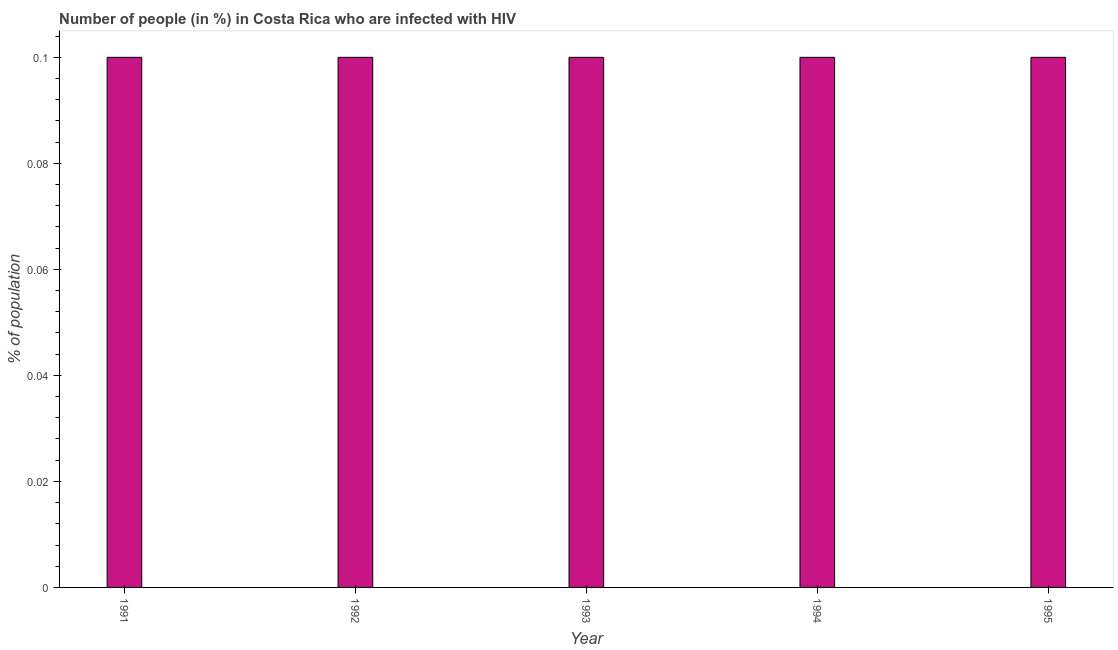Does the graph contain grids?
Offer a terse response. No. What is the title of the graph?
Your answer should be compact. Number of people (in %) in Costa Rica who are infected with HIV. What is the label or title of the Y-axis?
Your answer should be compact. % of population. In which year was the number of people infected with hiv maximum?
Your response must be concise. 1991. What is the sum of the number of people infected with hiv?
Your response must be concise. 0.5. What is the difference between the number of people infected with hiv in 1992 and 1994?
Your answer should be very brief. 0. What is the average number of people infected with hiv per year?
Your response must be concise. 0.1. In how many years, is the number of people infected with hiv greater than 0.084 %?
Ensure brevity in your answer.  5. Is the number of people infected with hiv in 1993 less than that in 1995?
Provide a short and direct response. No. Is the difference between the number of people infected with hiv in 1991 and 1993 greater than the difference between any two years?
Offer a very short reply. Yes. Is the sum of the number of people infected with hiv in 1991 and 1992 greater than the maximum number of people infected with hiv across all years?
Keep it short and to the point. Yes. What is the difference between the highest and the lowest number of people infected with hiv?
Keep it short and to the point. 0. In how many years, is the number of people infected with hiv greater than the average number of people infected with hiv taken over all years?
Give a very brief answer. 0. Are all the bars in the graph horizontal?
Your response must be concise. No. What is the difference between two consecutive major ticks on the Y-axis?
Offer a very short reply. 0.02. Are the values on the major ticks of Y-axis written in scientific E-notation?
Make the answer very short. No. What is the % of population in 1992?
Provide a succinct answer. 0.1. What is the % of population of 1995?
Ensure brevity in your answer.  0.1. What is the difference between the % of population in 1991 and 1992?
Make the answer very short. 0. What is the difference between the % of population in 1992 and 1993?
Offer a very short reply. 0. What is the difference between the % of population in 1992 and 1994?
Offer a very short reply. 0. What is the difference between the % of population in 1994 and 1995?
Give a very brief answer. 0. What is the ratio of the % of population in 1991 to that in 1993?
Ensure brevity in your answer.  1. What is the ratio of the % of population in 1991 to that in 1995?
Your answer should be very brief. 1. What is the ratio of the % of population in 1994 to that in 1995?
Offer a terse response. 1. 